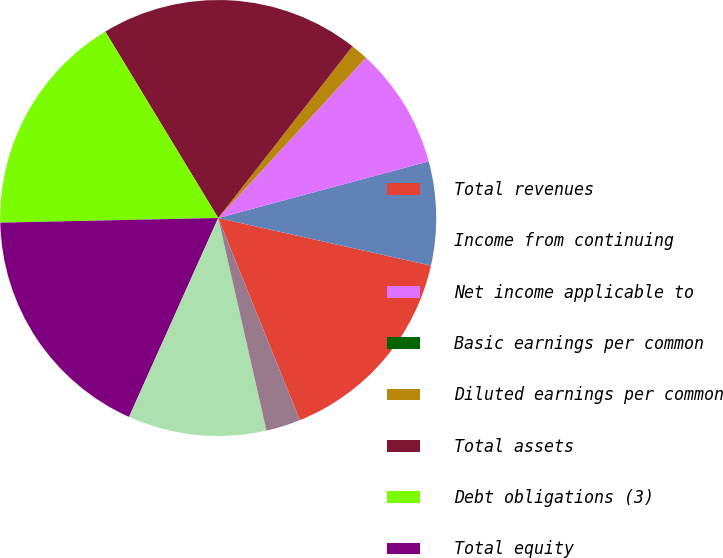<chart> <loc_0><loc_0><loc_500><loc_500><pie_chart><fcel>Total revenues<fcel>Income from continuing<fcel>Net income applicable to<fcel>Basic earnings per common<fcel>Diluted earnings per common<fcel>Total assets<fcel>Debt obligations (3)<fcel>Total equity<fcel>Dividends paid<fcel>Dividends paid per common<nl><fcel>15.38%<fcel>7.69%<fcel>8.97%<fcel>0.0%<fcel>1.28%<fcel>19.23%<fcel>16.67%<fcel>17.95%<fcel>10.26%<fcel>2.56%<nl></chart> 